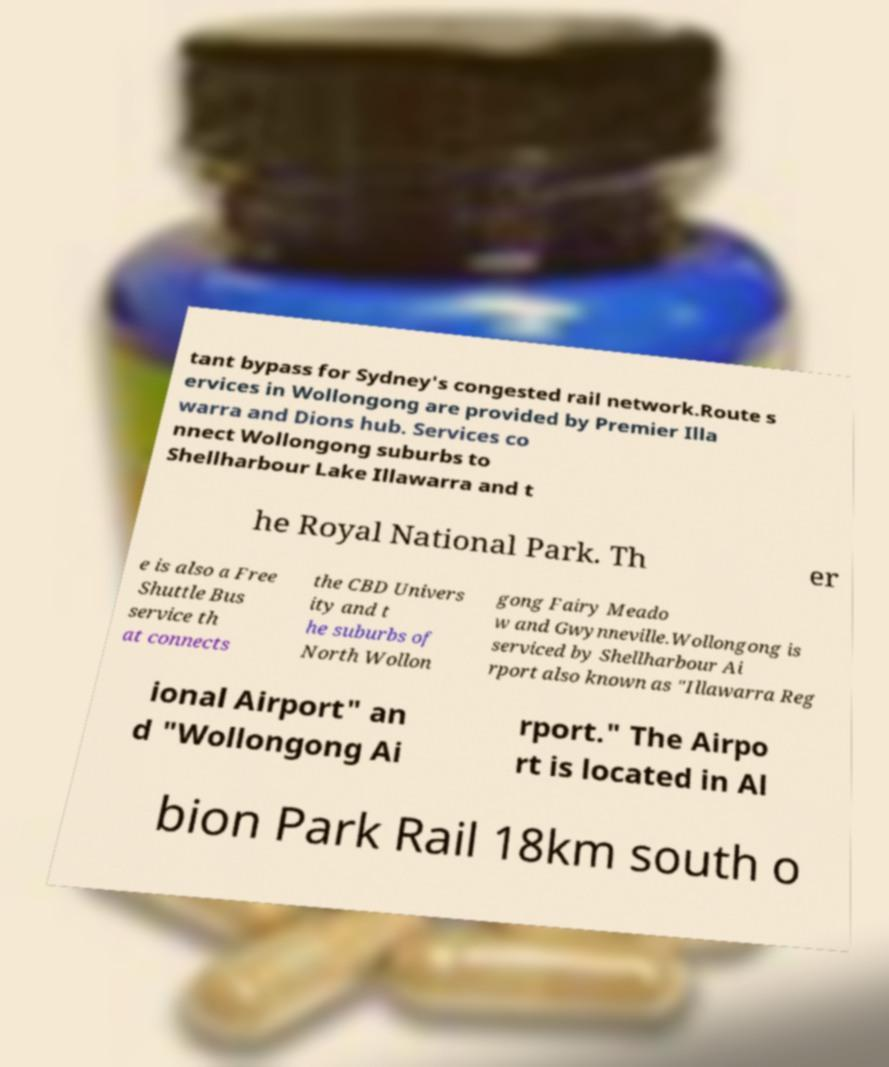Can you accurately transcribe the text from the provided image for me? tant bypass for Sydney's congested rail network.Route s ervices in Wollongong are provided by Premier Illa warra and Dions hub. Services co nnect Wollongong suburbs to Shellharbour Lake Illawarra and t he Royal National Park. Th er e is also a Free Shuttle Bus service th at connects the CBD Univers ity and t he suburbs of North Wollon gong Fairy Meado w and Gwynneville.Wollongong is serviced by Shellharbour Ai rport also known as "Illawarra Reg ional Airport" an d "Wollongong Ai rport." The Airpo rt is located in Al bion Park Rail 18km south o 